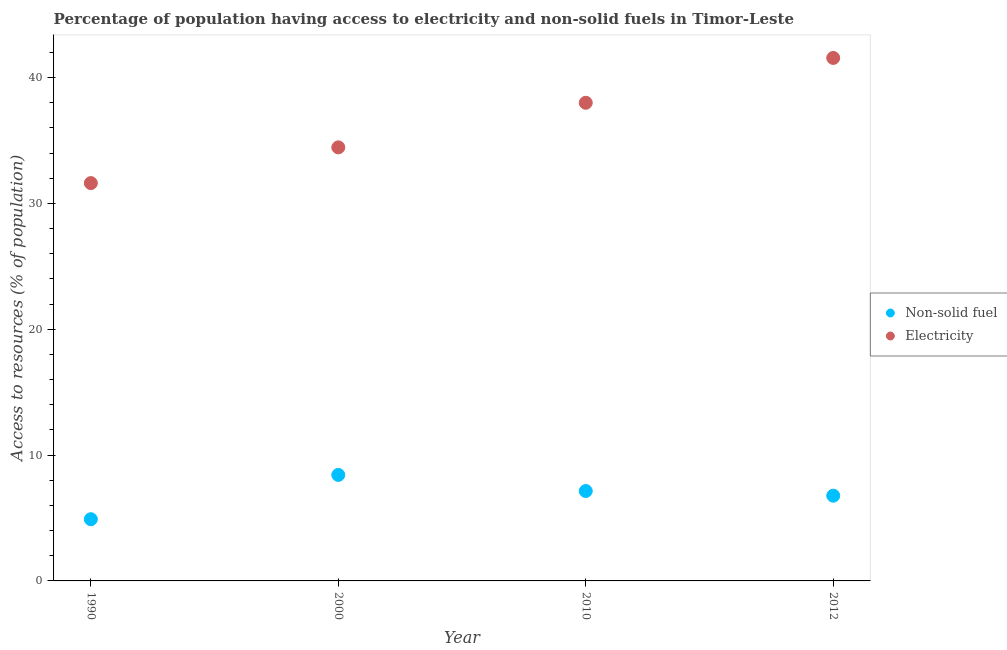What is the percentage of population having access to electricity in 2012?
Your answer should be very brief. 41.56. Across all years, what is the maximum percentage of population having access to non-solid fuel?
Ensure brevity in your answer.  8.43. Across all years, what is the minimum percentage of population having access to electricity?
Your answer should be compact. 31.62. In which year was the percentage of population having access to non-solid fuel maximum?
Make the answer very short. 2000. What is the total percentage of population having access to electricity in the graph?
Keep it short and to the point. 145.63. What is the difference between the percentage of population having access to electricity in 2000 and that in 2012?
Give a very brief answer. -7.11. What is the difference between the percentage of population having access to non-solid fuel in 2010 and the percentage of population having access to electricity in 1990?
Keep it short and to the point. -24.47. What is the average percentage of population having access to electricity per year?
Your response must be concise. 36.41. In the year 1990, what is the difference between the percentage of population having access to non-solid fuel and percentage of population having access to electricity?
Give a very brief answer. -26.71. In how many years, is the percentage of population having access to non-solid fuel greater than 38 %?
Your answer should be very brief. 0. What is the ratio of the percentage of population having access to electricity in 2000 to that in 2012?
Make the answer very short. 0.83. What is the difference between the highest and the second highest percentage of population having access to non-solid fuel?
Offer a very short reply. 1.28. What is the difference between the highest and the lowest percentage of population having access to electricity?
Offer a very short reply. 9.95. In how many years, is the percentage of population having access to non-solid fuel greater than the average percentage of population having access to non-solid fuel taken over all years?
Provide a short and direct response. 2. Does the percentage of population having access to non-solid fuel monotonically increase over the years?
Ensure brevity in your answer.  No. Is the percentage of population having access to non-solid fuel strictly greater than the percentage of population having access to electricity over the years?
Provide a short and direct response. No. Is the percentage of population having access to non-solid fuel strictly less than the percentage of population having access to electricity over the years?
Provide a succinct answer. Yes. How many years are there in the graph?
Keep it short and to the point. 4. Are the values on the major ticks of Y-axis written in scientific E-notation?
Give a very brief answer. No. Does the graph contain any zero values?
Your answer should be very brief. No. Does the graph contain grids?
Offer a very short reply. No. How many legend labels are there?
Make the answer very short. 2. How are the legend labels stacked?
Offer a very short reply. Vertical. What is the title of the graph?
Ensure brevity in your answer.  Percentage of population having access to electricity and non-solid fuels in Timor-Leste. Does "Technicians" appear as one of the legend labels in the graph?
Ensure brevity in your answer.  No. What is the label or title of the X-axis?
Give a very brief answer. Year. What is the label or title of the Y-axis?
Ensure brevity in your answer.  Access to resources (% of population). What is the Access to resources (% of population) of Non-solid fuel in 1990?
Make the answer very short. 4.9. What is the Access to resources (% of population) in Electricity in 1990?
Give a very brief answer. 31.62. What is the Access to resources (% of population) in Non-solid fuel in 2000?
Give a very brief answer. 8.43. What is the Access to resources (% of population) in Electricity in 2000?
Ensure brevity in your answer.  34.46. What is the Access to resources (% of population) of Non-solid fuel in 2010?
Offer a terse response. 7.14. What is the Access to resources (% of population) of Non-solid fuel in 2012?
Ensure brevity in your answer.  6.77. What is the Access to resources (% of population) of Electricity in 2012?
Your answer should be compact. 41.56. Across all years, what is the maximum Access to resources (% of population) in Non-solid fuel?
Make the answer very short. 8.43. Across all years, what is the maximum Access to resources (% of population) in Electricity?
Offer a terse response. 41.56. Across all years, what is the minimum Access to resources (% of population) of Non-solid fuel?
Ensure brevity in your answer.  4.9. Across all years, what is the minimum Access to resources (% of population) of Electricity?
Offer a terse response. 31.62. What is the total Access to resources (% of population) in Non-solid fuel in the graph?
Offer a terse response. 27.25. What is the total Access to resources (% of population) in Electricity in the graph?
Ensure brevity in your answer.  145.63. What is the difference between the Access to resources (% of population) of Non-solid fuel in 1990 and that in 2000?
Provide a short and direct response. -3.52. What is the difference between the Access to resources (% of population) in Electricity in 1990 and that in 2000?
Ensure brevity in your answer.  -2.84. What is the difference between the Access to resources (% of population) in Non-solid fuel in 1990 and that in 2010?
Ensure brevity in your answer.  -2.24. What is the difference between the Access to resources (% of population) of Electricity in 1990 and that in 2010?
Give a very brief answer. -6.38. What is the difference between the Access to resources (% of population) of Non-solid fuel in 1990 and that in 2012?
Make the answer very short. -1.87. What is the difference between the Access to resources (% of population) of Electricity in 1990 and that in 2012?
Your response must be concise. -9.95. What is the difference between the Access to resources (% of population) of Non-solid fuel in 2000 and that in 2010?
Your answer should be very brief. 1.28. What is the difference between the Access to resources (% of population) of Electricity in 2000 and that in 2010?
Your response must be concise. -3.54. What is the difference between the Access to resources (% of population) in Non-solid fuel in 2000 and that in 2012?
Your answer should be compact. 1.65. What is the difference between the Access to resources (% of population) in Electricity in 2000 and that in 2012?
Offer a terse response. -7.11. What is the difference between the Access to resources (% of population) in Non-solid fuel in 2010 and that in 2012?
Offer a very short reply. 0.37. What is the difference between the Access to resources (% of population) in Electricity in 2010 and that in 2012?
Your answer should be compact. -3.56. What is the difference between the Access to resources (% of population) of Non-solid fuel in 1990 and the Access to resources (% of population) of Electricity in 2000?
Give a very brief answer. -29.55. What is the difference between the Access to resources (% of population) of Non-solid fuel in 1990 and the Access to resources (% of population) of Electricity in 2010?
Your response must be concise. -33.1. What is the difference between the Access to resources (% of population) of Non-solid fuel in 1990 and the Access to resources (% of population) of Electricity in 2012?
Your answer should be compact. -36.66. What is the difference between the Access to resources (% of population) in Non-solid fuel in 2000 and the Access to resources (% of population) in Electricity in 2010?
Offer a terse response. -29.57. What is the difference between the Access to resources (% of population) in Non-solid fuel in 2000 and the Access to resources (% of population) in Electricity in 2012?
Provide a short and direct response. -33.14. What is the difference between the Access to resources (% of population) in Non-solid fuel in 2010 and the Access to resources (% of population) in Electricity in 2012?
Your response must be concise. -34.42. What is the average Access to resources (% of population) of Non-solid fuel per year?
Give a very brief answer. 6.81. What is the average Access to resources (% of population) in Electricity per year?
Make the answer very short. 36.41. In the year 1990, what is the difference between the Access to resources (% of population) in Non-solid fuel and Access to resources (% of population) in Electricity?
Make the answer very short. -26.71. In the year 2000, what is the difference between the Access to resources (% of population) of Non-solid fuel and Access to resources (% of population) of Electricity?
Ensure brevity in your answer.  -26.03. In the year 2010, what is the difference between the Access to resources (% of population) in Non-solid fuel and Access to resources (% of population) in Electricity?
Provide a short and direct response. -30.86. In the year 2012, what is the difference between the Access to resources (% of population) of Non-solid fuel and Access to resources (% of population) of Electricity?
Keep it short and to the point. -34.79. What is the ratio of the Access to resources (% of population) of Non-solid fuel in 1990 to that in 2000?
Your answer should be compact. 0.58. What is the ratio of the Access to resources (% of population) in Electricity in 1990 to that in 2000?
Give a very brief answer. 0.92. What is the ratio of the Access to resources (% of population) in Non-solid fuel in 1990 to that in 2010?
Offer a very short reply. 0.69. What is the ratio of the Access to resources (% of population) of Electricity in 1990 to that in 2010?
Provide a short and direct response. 0.83. What is the ratio of the Access to resources (% of population) of Non-solid fuel in 1990 to that in 2012?
Offer a terse response. 0.72. What is the ratio of the Access to resources (% of population) in Electricity in 1990 to that in 2012?
Make the answer very short. 0.76. What is the ratio of the Access to resources (% of population) of Non-solid fuel in 2000 to that in 2010?
Your response must be concise. 1.18. What is the ratio of the Access to resources (% of population) in Electricity in 2000 to that in 2010?
Keep it short and to the point. 0.91. What is the ratio of the Access to resources (% of population) in Non-solid fuel in 2000 to that in 2012?
Your answer should be compact. 1.24. What is the ratio of the Access to resources (% of population) of Electricity in 2000 to that in 2012?
Provide a succinct answer. 0.83. What is the ratio of the Access to resources (% of population) of Non-solid fuel in 2010 to that in 2012?
Offer a very short reply. 1.05. What is the ratio of the Access to resources (% of population) of Electricity in 2010 to that in 2012?
Keep it short and to the point. 0.91. What is the difference between the highest and the second highest Access to resources (% of population) of Non-solid fuel?
Provide a short and direct response. 1.28. What is the difference between the highest and the second highest Access to resources (% of population) of Electricity?
Your answer should be very brief. 3.56. What is the difference between the highest and the lowest Access to resources (% of population) of Non-solid fuel?
Your answer should be very brief. 3.52. What is the difference between the highest and the lowest Access to resources (% of population) of Electricity?
Your response must be concise. 9.95. 